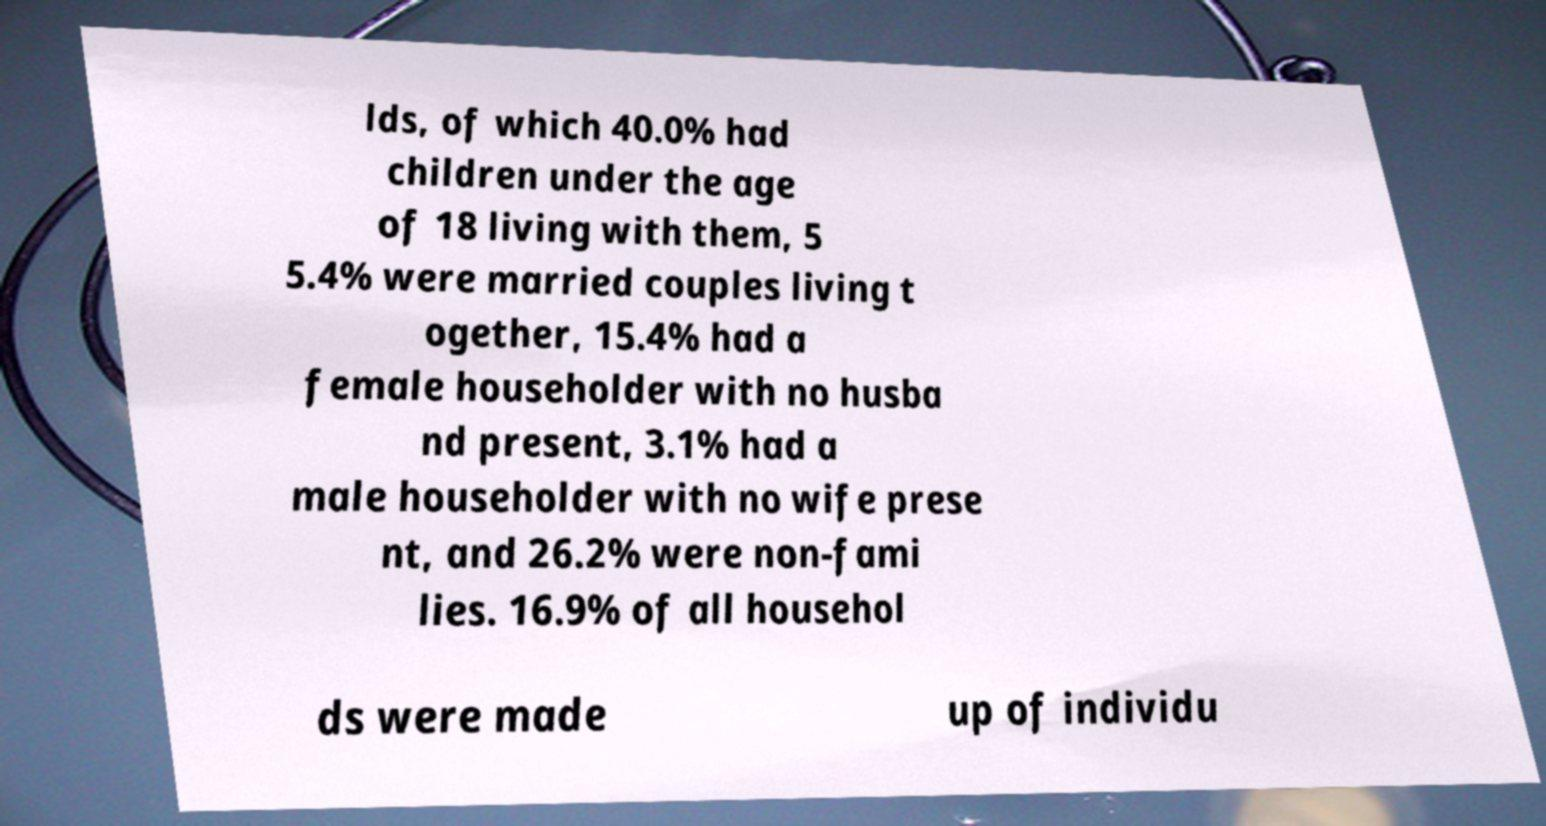For documentation purposes, I need the text within this image transcribed. Could you provide that? lds, of which 40.0% had children under the age of 18 living with them, 5 5.4% were married couples living t ogether, 15.4% had a female householder with no husba nd present, 3.1% had a male householder with no wife prese nt, and 26.2% were non-fami lies. 16.9% of all househol ds were made up of individu 